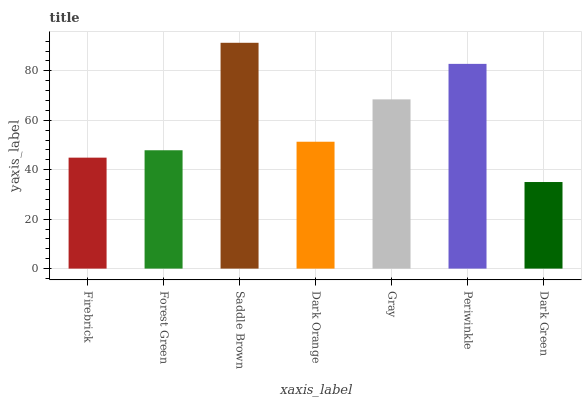Is Dark Green the minimum?
Answer yes or no. Yes. Is Saddle Brown the maximum?
Answer yes or no. Yes. Is Forest Green the minimum?
Answer yes or no. No. Is Forest Green the maximum?
Answer yes or no. No. Is Forest Green greater than Firebrick?
Answer yes or no. Yes. Is Firebrick less than Forest Green?
Answer yes or no. Yes. Is Firebrick greater than Forest Green?
Answer yes or no. No. Is Forest Green less than Firebrick?
Answer yes or no. No. Is Dark Orange the high median?
Answer yes or no. Yes. Is Dark Orange the low median?
Answer yes or no. Yes. Is Saddle Brown the high median?
Answer yes or no. No. Is Dark Green the low median?
Answer yes or no. No. 